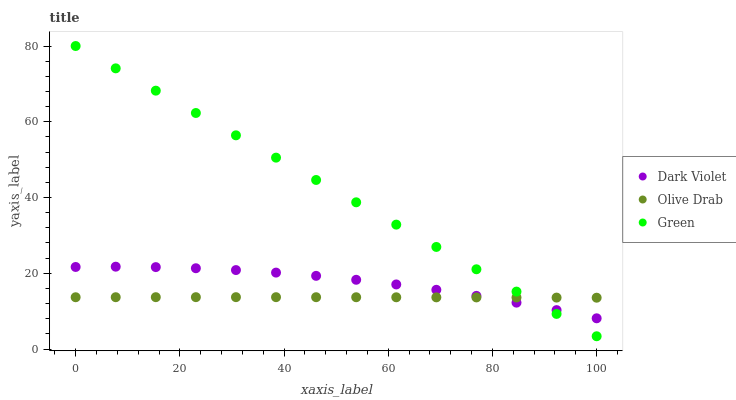Does Olive Drab have the minimum area under the curve?
Answer yes or no. Yes. Does Green have the maximum area under the curve?
Answer yes or no. Yes. Does Dark Violet have the minimum area under the curve?
Answer yes or no. No. Does Dark Violet have the maximum area under the curve?
Answer yes or no. No. Is Green the smoothest?
Answer yes or no. Yes. Is Dark Violet the roughest?
Answer yes or no. Yes. Is Olive Drab the smoothest?
Answer yes or no. No. Is Olive Drab the roughest?
Answer yes or no. No. Does Green have the lowest value?
Answer yes or no. Yes. Does Dark Violet have the lowest value?
Answer yes or no. No. Does Green have the highest value?
Answer yes or no. Yes. Does Dark Violet have the highest value?
Answer yes or no. No. Does Olive Drab intersect Green?
Answer yes or no. Yes. Is Olive Drab less than Green?
Answer yes or no. No. Is Olive Drab greater than Green?
Answer yes or no. No. 